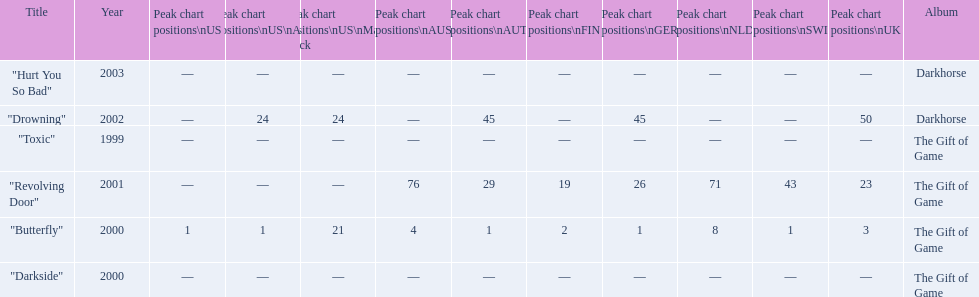How many times did the single "butterfly" rank as 1 in the chart? 5. 